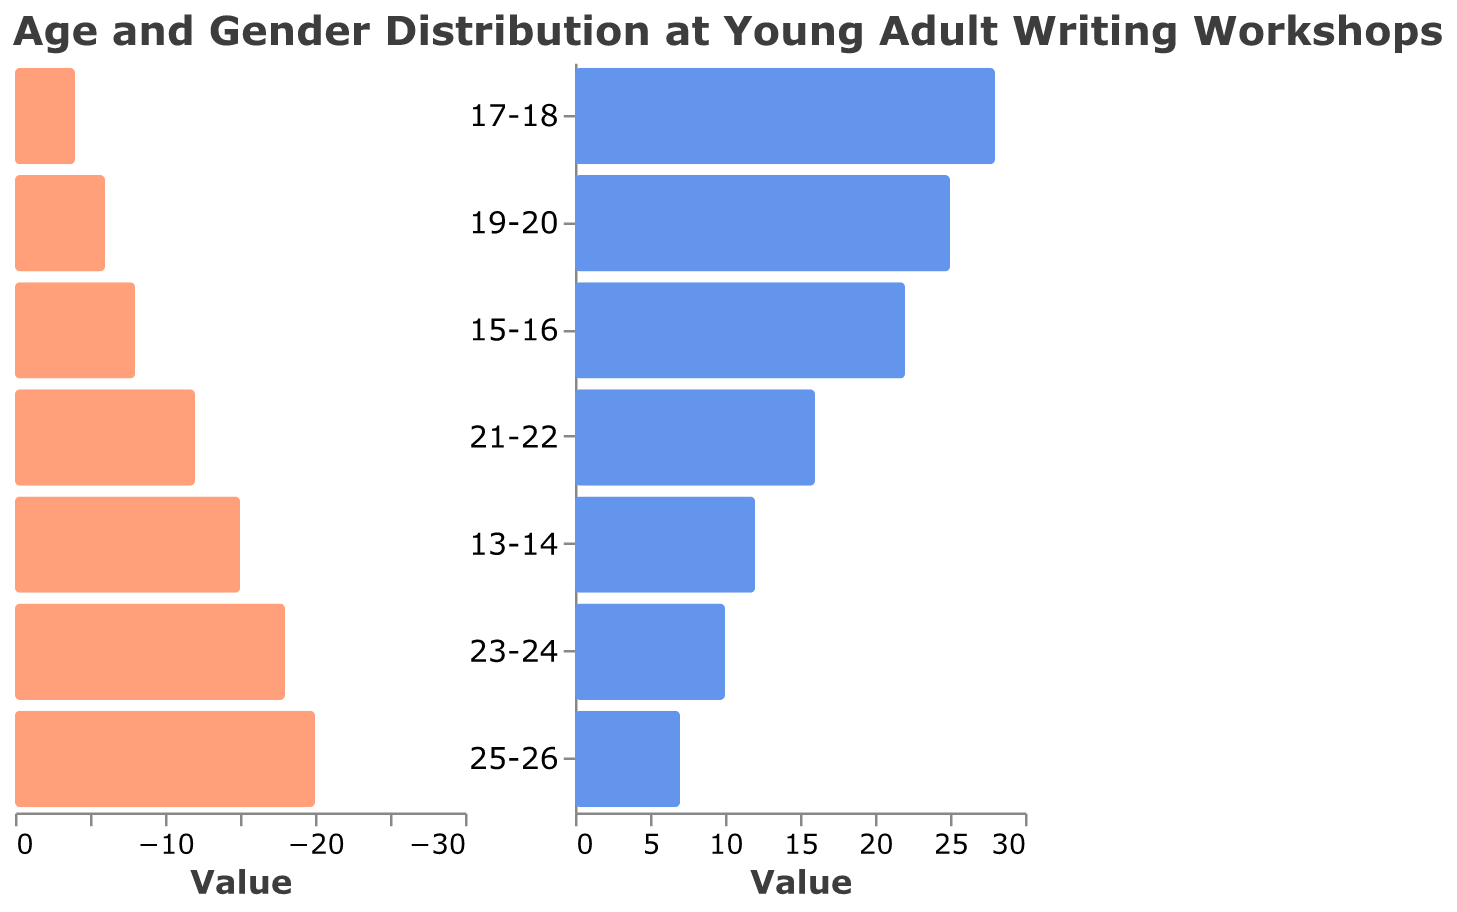What is the title of the chart? The title of the chart is positioned at the top and provides an overall description of the chart’s content: "Age and Gender Distribution at Young Adult Writing Workshops".
Answer: Age and Gender Distribution at Young Adult Writing Workshops What age group has the highest number of female attendees? By examining the bars representing female attendees, the age group with the longest bar (indicating the highest number) can be identified. The age group 17-18 has the longest bar for females.
Answer: 17-18 How many male attendees are there in the 19-20 age group? By looking at the negative side of the chart (left side for male data), find the bar corresponding to the 19-20 age group. The value indicated is 18.
Answer: 18 Which gender has more attendees in the 21-22 age group? Compare the lengths of the bars for males and females in the 21-22 age group. The bar on the right representing females is longer than the bar on the left representing males.
Answer: Female What is the total number of attendees in the age group 15-16? Add the number of male and female attendees in the age group 15-16. Males: 15; Females: 22. Total = 15 + 22 = 37.
Answer: 37 Which age group has the smallest number of female attendees? Examine the bars representing females and identify the shortest one. The age group 25-26 has the shortest female bar with 7 attendees.
Answer: 25-26 How does the number of male and female attendees compare in the 13-14 age group? Compare the lengths of the bars for males and females in the 13-14 age group. There are 8 males and 12 females, indicating more females than males.
Answer: Females outnumber males What is the total number of attendees across all age groups for males and females separately? Sum up the number of male and female attendees for each age group. Males: 8+15+20+18+12+6+4 = 83. Females: 12+22+28+25+16+10+7=120.
Answer: Males: 83, Females: 120 Which age group shows the greatest gender disparity and in favor of which gender? Calculate the difference in attendees between the genders for each age group and identify the largest difference. The age group 17-18, with males: 20, females: 28, has a disparity of 8 in favor of females.
Answer: 17-18 in favor of females What is the average number of attendees per age group for both genders combined? Sum the total number of attendees and divide by the number of age groups. Total attendees: 83 (males) + 120 (females) = 203. Number of age groups: 7. Average = 203 / 7 ≈ 29.
Answer: 29 